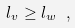<formula> <loc_0><loc_0><loc_500><loc_500>l _ { v } \geq l _ { w } \ ,</formula> 